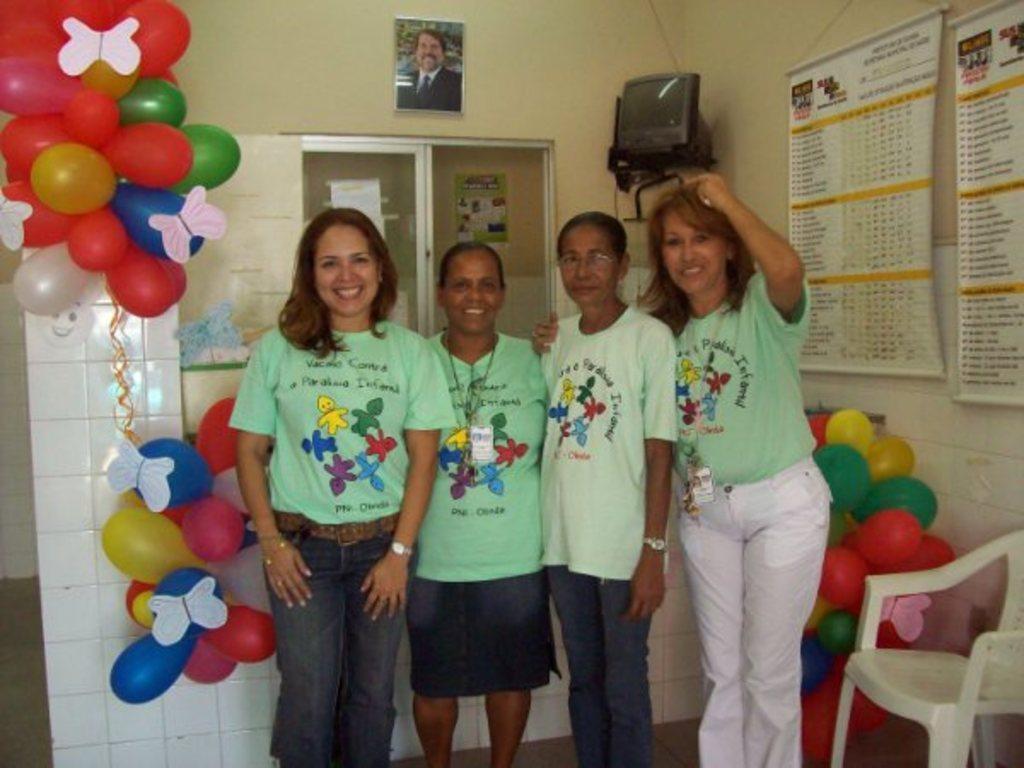Describe this image in one or two sentences. There are four ladies standing with green color t-shirt. To their left side there are balloons, and a pillar. And to the right side there is a pillar. And to the right bottom there is a white color chair and balloons are there. In the background there is a window with glass. On the top there is a frame. In the corner there is a TV. 